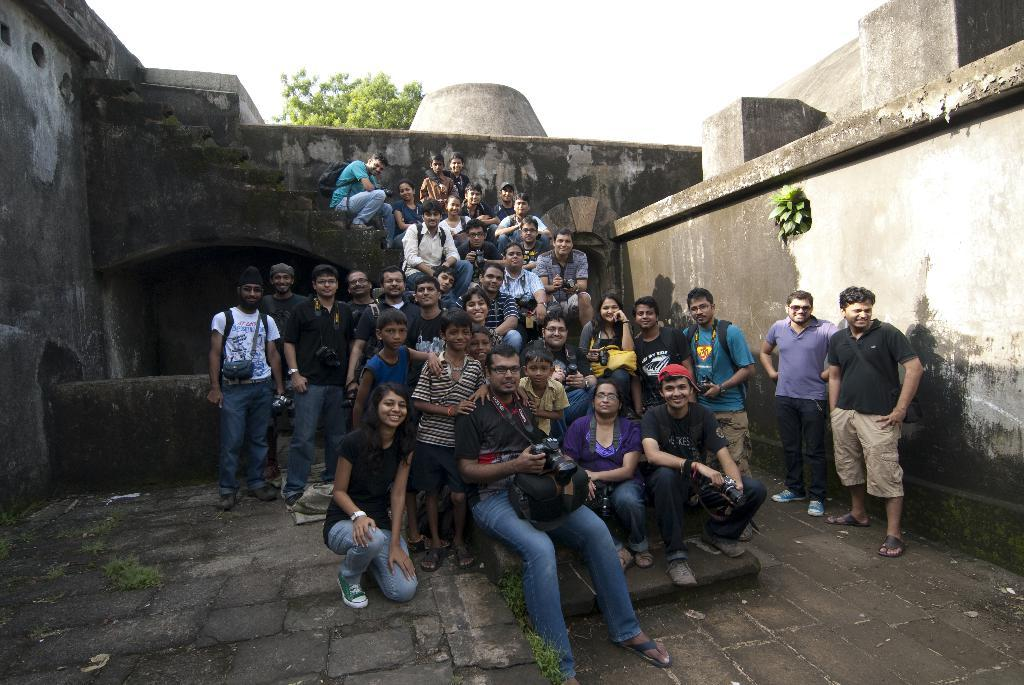How many people are in the image? There is a group of people in the image, but the exact number is not specified. What are the people in the image doing? Some people are sitting, while others are standing. Can you describe the construction in the image? The construction in the image appears to be old. What type of vegetation is visible in the image? There is a tree visible at the back side of the image. What is visible at the top of the image? The sky is visible at the top of the image. What color is the nose of the person standing in the image? There is no mention of a nose or a specific person in the image, so it is not possible to answer that question. 